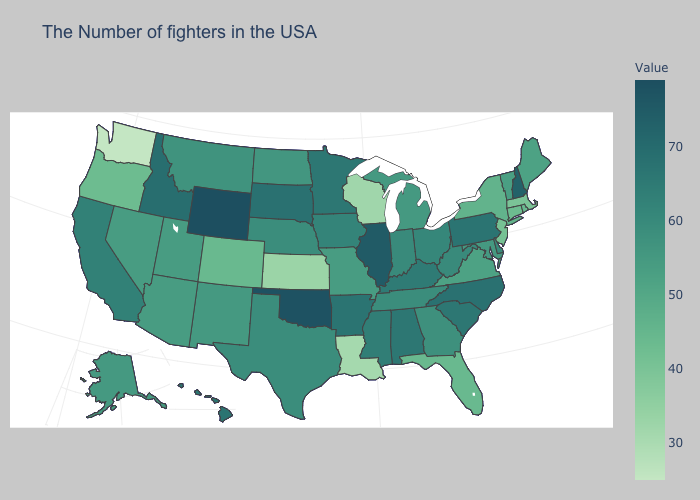Does New Hampshire have the lowest value in the USA?
Answer briefly. No. Does Rhode Island have the lowest value in the USA?
Short answer required. No. Does Illinois have the highest value in the MidWest?
Quick response, please. Yes. Among the states that border Louisiana , which have the highest value?
Be succinct. Arkansas. Among the states that border Indiana , does Michigan have the highest value?
Write a very short answer. No. Does Wisconsin have the lowest value in the MidWest?
Answer briefly. Yes. 